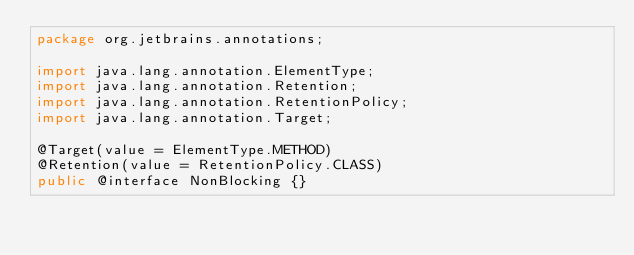<code> <loc_0><loc_0><loc_500><loc_500><_Java_>package org.jetbrains.annotations;

import java.lang.annotation.ElementType;
import java.lang.annotation.Retention;
import java.lang.annotation.RetentionPolicy;
import java.lang.annotation.Target;

@Target(value = ElementType.METHOD)
@Retention(value = RetentionPolicy.CLASS)
public @interface NonBlocking {}
</code> 